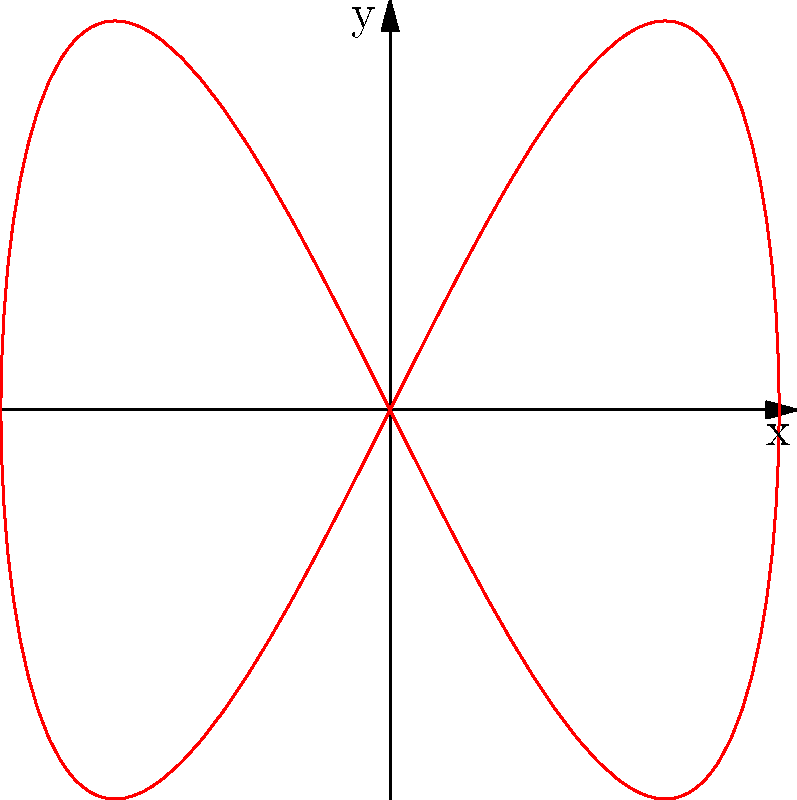As a software product manager integrating Lua functionality into your application, you need to implement a feature that generates and displays parametric curves. Create a Lua function that generates points for the parametric curve defined by $x = \cos(t)$ and $y = \sin(2t)$ for $t \in [0, 2\pi]$. What is the shape of this curve, and how many lobes does it have? To understand the shape of this parametric curve, let's analyze its properties:

1. The curve is defined by:
   $x = \cos(t)$
   $y = \sin(2t)$
   where $t \in [0, 2\pi]$

2. Observe that $x$ has a period of $2\pi$, while $y$ has a period of $\pi$.

3. When $t = 0$:
   $x = \cos(0) = 1$
   $y = \sin(0) = 0$

4. When $t = \pi/2$:
   $x = \cos(\pi/2) = 0$
   $y = \sin(\pi) = 0$

5. When $t = \pi$:
   $x = \cos(\pi) = -1$
   $y = \sin(2\pi) = 0$

6. When $t = 3\pi/2$:
   $x = \cos(3\pi/2) = 0$
   $y = \sin(3\pi) = 0$

7. When $t = 2\pi$:
   $x = \cos(2\pi) = 1$
   $y = \sin(4\pi) = 0$

8. The curve starts at (1,0), goes through (0,0) twice, reaches (-1,0), and then returns to (1,0).

9. Due to the double frequency of the sine function in $y$, the curve completes two vertical oscillations for each horizontal oscillation.

From this analysis, we can conclude that the curve forms a figure-eight shape, also known as a lemniscate. It has two lobes, one on each side of the y-axis.
Answer: Figure-eight (lemniscate) with 2 lobes 